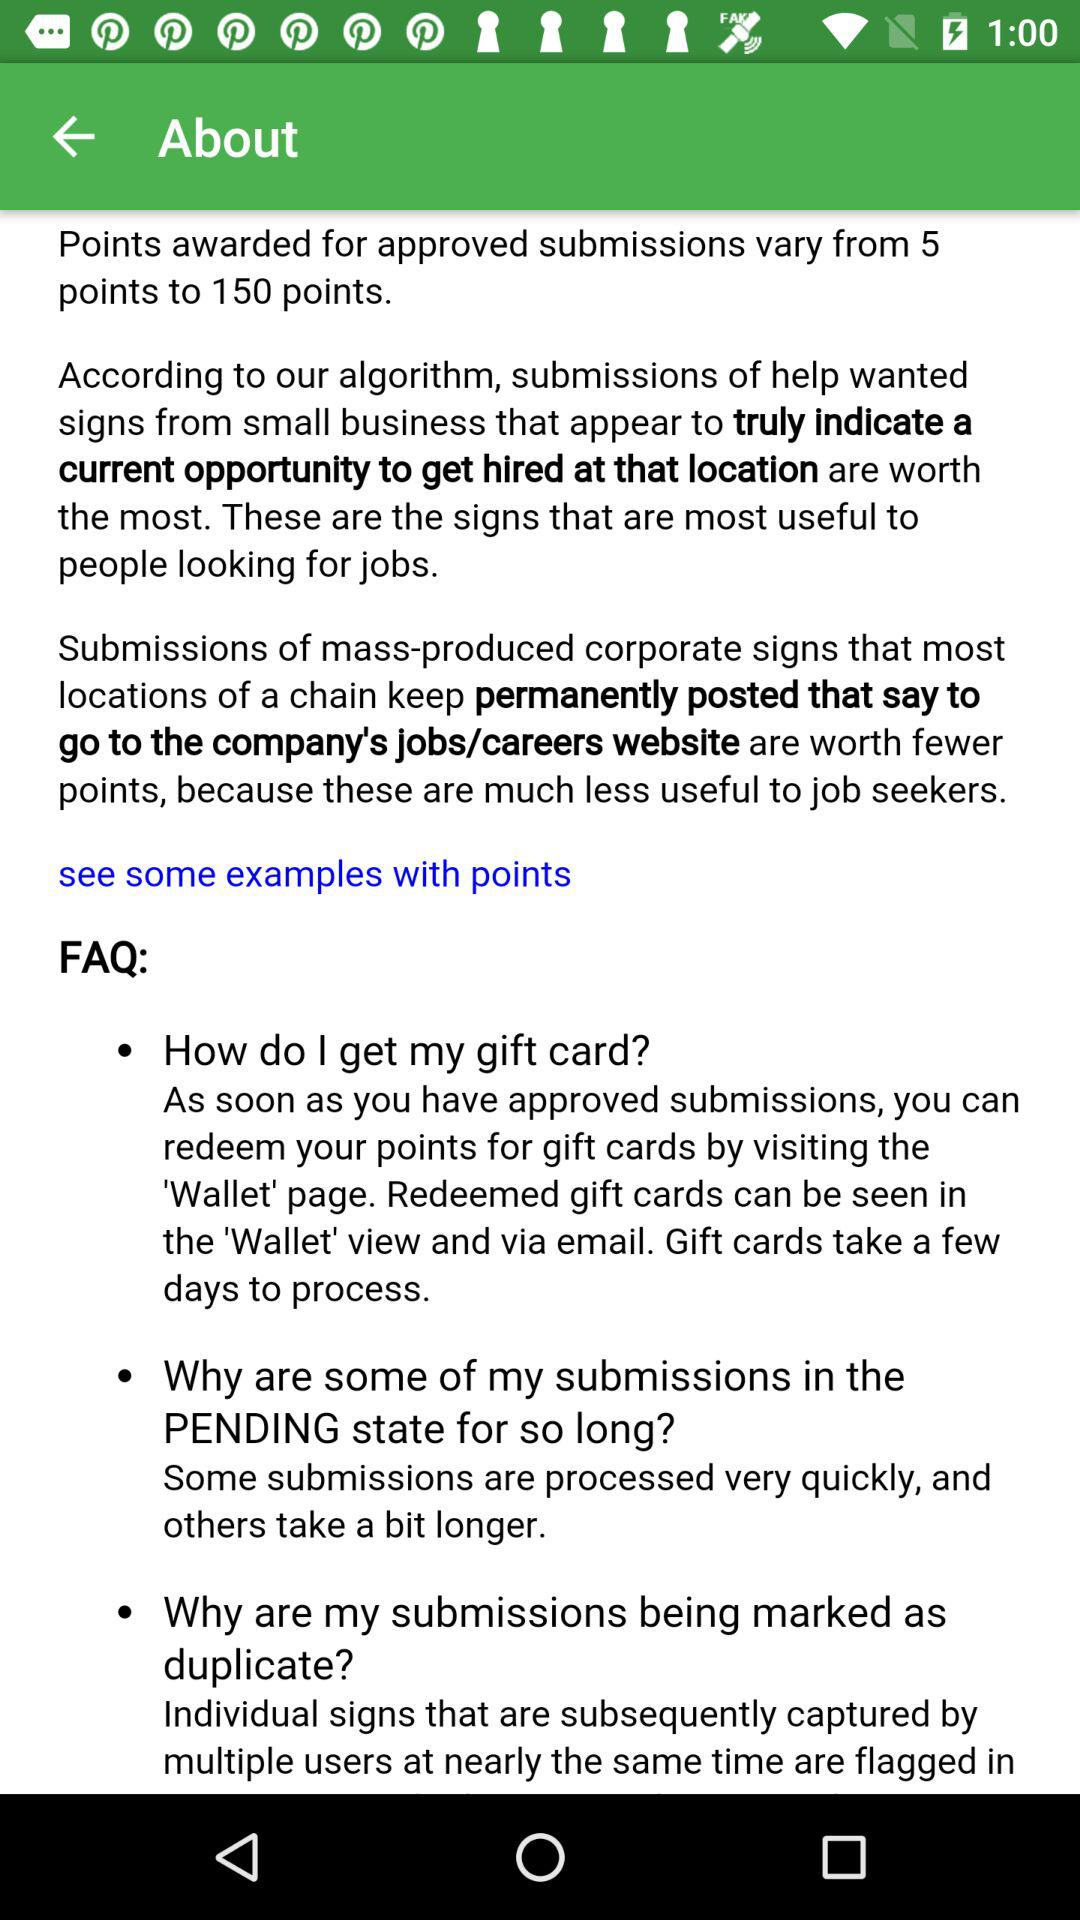How many FAQs are there?
Answer the question using a single word or phrase. 3 